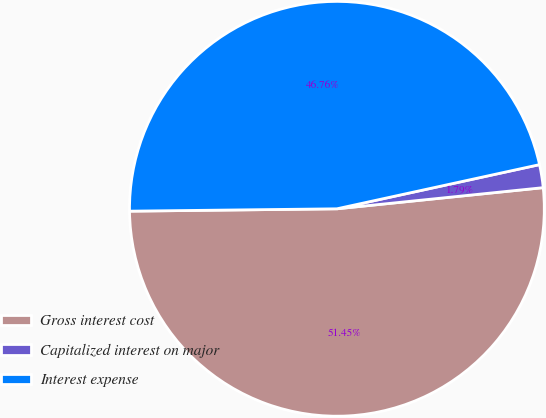Convert chart. <chart><loc_0><loc_0><loc_500><loc_500><pie_chart><fcel>Gross interest cost<fcel>Capitalized interest on major<fcel>Interest expense<nl><fcel>51.44%<fcel>1.79%<fcel>46.76%<nl></chart> 